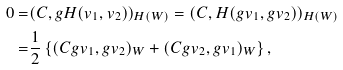Convert formula to latex. <formula><loc_0><loc_0><loc_500><loc_500>0 = & ( C , g H ( v _ { 1 } , v _ { 2 } ) ) _ { H ( W ) } = ( C , H ( g v _ { 1 } , g v _ { 2 } ) ) _ { H ( W ) } \\ = & \frac { 1 } { 2 } \left \{ ( C g v _ { 1 } , g v _ { 2 } ) _ { W } + ( C g v _ { 2 } , g v _ { 1 } ) _ { W } \right \} ,</formula> 